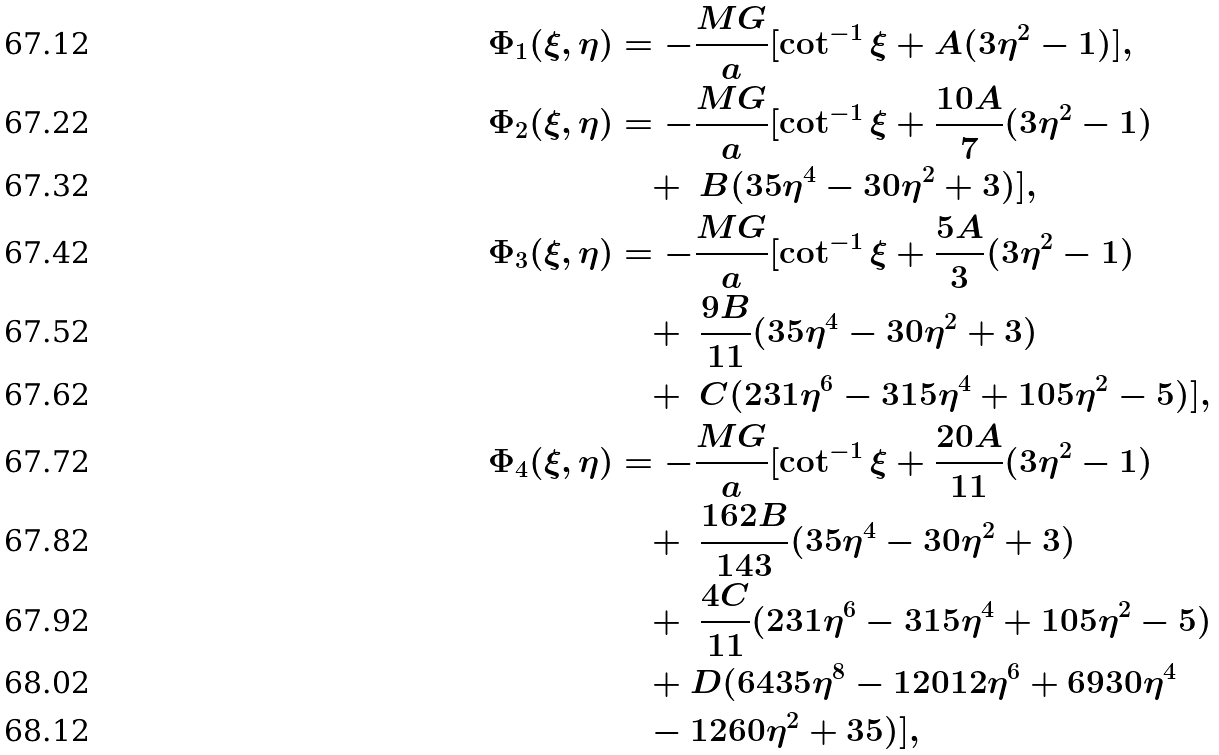Convert formula to latex. <formula><loc_0><loc_0><loc_500><loc_500>\Phi _ { 1 } ( \xi , \eta ) & = - \frac { M G } { a } [ \cot ^ { - 1 } \xi + A ( 3 \eta ^ { 2 } - 1 ) ] , \\ \Phi _ { 2 } ( \xi , \eta ) & = - \frac { M G } { a } [ \cot ^ { - 1 } \xi + \frac { 1 0 A } { 7 } ( 3 \eta ^ { 2 } - 1 ) \\ & \quad + \ B ( 3 5 \eta ^ { 4 } - 3 0 \eta ^ { 2 } + 3 ) ] , \\ \Phi _ { 3 } ( \xi , \eta ) & = - \frac { M G } { a } [ \cot ^ { - 1 } \xi + \frac { 5 A } { 3 } ( 3 \eta ^ { 2 } - 1 ) \\ & \quad + \ \frac { 9 B } { 1 1 } ( 3 5 \eta ^ { 4 } - 3 0 \eta ^ { 2 } + 3 ) \\ & \quad + \ C ( 2 3 1 \eta ^ { 6 } - 3 1 5 \eta ^ { 4 } + 1 0 5 \eta ^ { 2 } - 5 ) ] , \\ \Phi _ { 4 } ( \xi , \eta ) & = - \frac { M G } { a } [ \cot ^ { - 1 } \xi + \frac { 2 0 A } { 1 1 } ( 3 \eta ^ { 2 } - 1 ) \\ & \quad + \ \frac { 1 6 2 B } { 1 4 3 } ( 3 5 \eta ^ { 4 } - 3 0 \eta ^ { 2 } + 3 ) \\ & \quad + \ \frac { 4 C } { 1 1 } ( 2 3 1 \eta ^ { 6 } - 3 1 5 \eta ^ { 4 } + 1 0 5 \eta ^ { 2 } - 5 ) \\ & \quad + D ( 6 4 3 5 \eta ^ { 8 } - 1 2 0 1 2 \eta ^ { 6 } + 6 9 3 0 \eta ^ { 4 } \\ & \quad - 1 2 6 0 \eta ^ { 2 } + 3 5 ) ] ,</formula> 